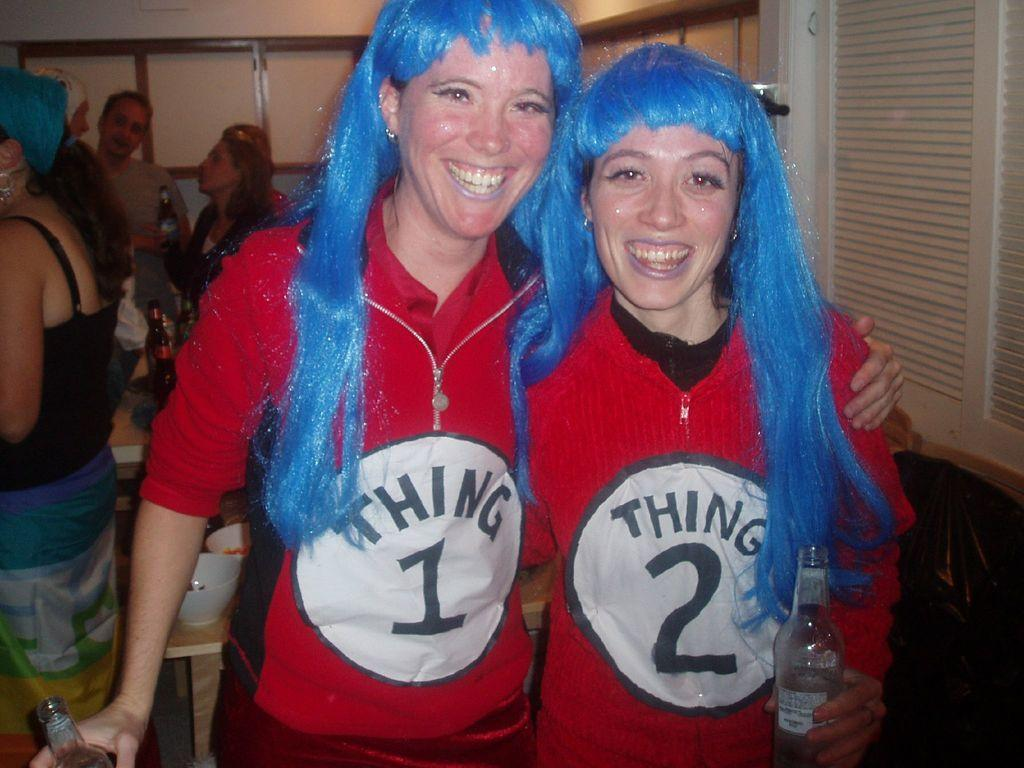Provide a one-sentence caption for the provided image. Two women dressed up as Thing 1 and Thing 2. 